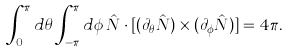Convert formula to latex. <formula><loc_0><loc_0><loc_500><loc_500>\int ^ { \pi } _ { 0 } d \theta \int ^ { \pi } _ { - \pi } d \phi \, \hat { N } \cdot [ ( \partial _ { \theta } \hat { N } ) \times ( \partial _ { \phi } \hat { N } ) ] = 4 \pi .</formula> 